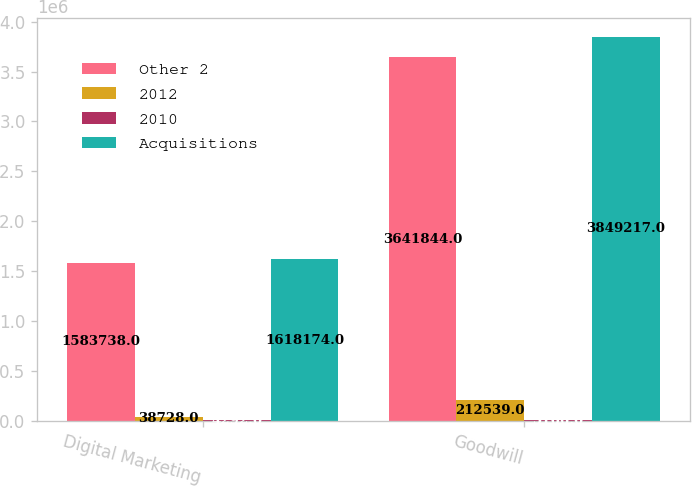<chart> <loc_0><loc_0><loc_500><loc_500><stacked_bar_chart><ecel><fcel>Digital Marketing<fcel>Goodwill<nl><fcel>Other 2<fcel>1.58374e+06<fcel>3.64184e+06<nl><fcel>2012<fcel>38728<fcel>212539<nl><fcel>2010<fcel>4292<fcel>5166<nl><fcel>Acquisitions<fcel>1.61817e+06<fcel>3.84922e+06<nl></chart> 